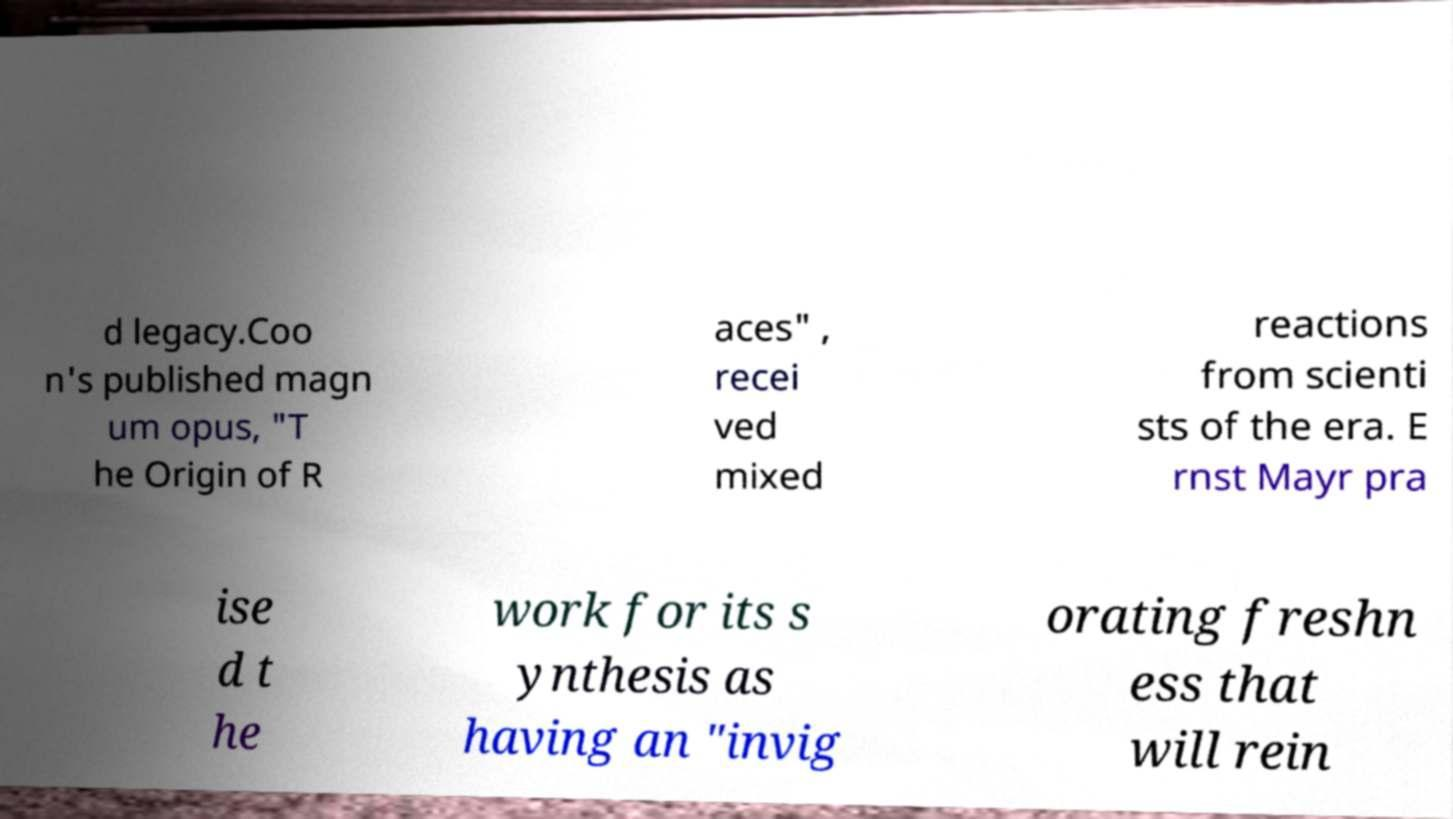Can you read and provide the text displayed in the image?This photo seems to have some interesting text. Can you extract and type it out for me? d legacy.Coo n's published magn um opus, "T he Origin of R aces" , recei ved mixed reactions from scienti sts of the era. E rnst Mayr pra ise d t he work for its s ynthesis as having an "invig orating freshn ess that will rein 